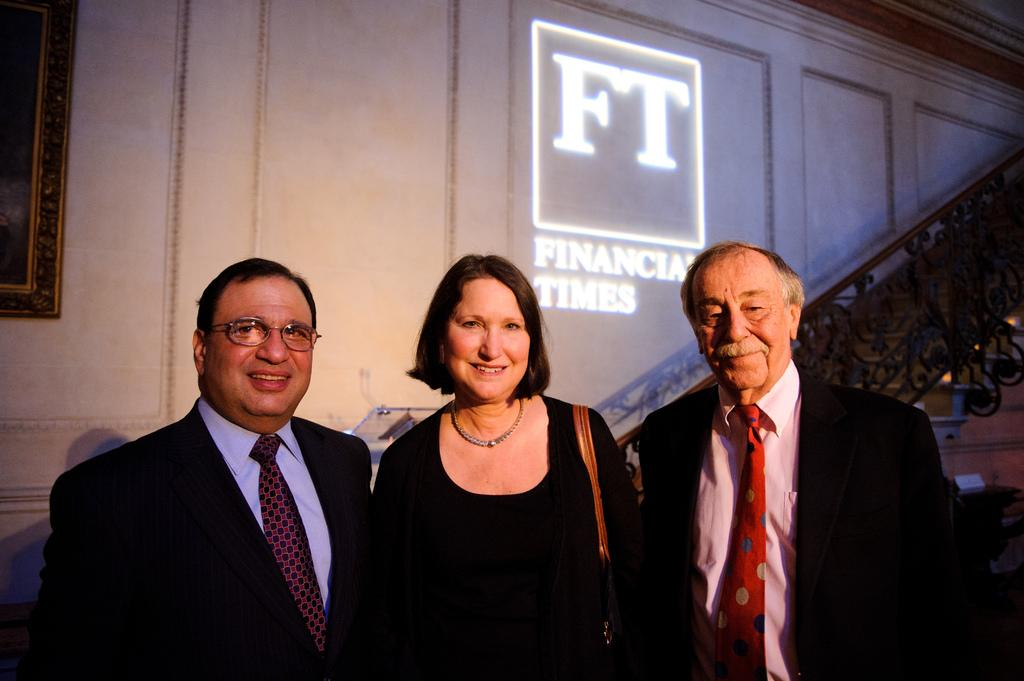How many people are in the image? There are three persons standing in the center of the image. What can be seen in the background of the image? There is a wall and a staircase in the background of the image. What is the staircase railing used for? The staircase railing is used for safety and support while using the staircase. Reasoning: Let's think step by identifying the main subjects and objects in the image based on the provided facts. We then formulate questions that focus on the location and characteristics of these subjects and objects, ensuring that each question can be answered definitively with the information given. We avoid yes/no questions and ensure that the language is simple and clear. Absurd Question/Answer: Can you see the ocean in the background of the image? No, there is no ocean visible in the image. Is there a hole in the floor in the image? No, there is no mention of a hole in the floor in the provided facts. How many geese are depicted on the poster? There are no geese depicted on the poster; it features a picture of a pot. What type of creature is shown interacting with the pot on the poster? There is no creature shown interacting with the pot on the poster; only the pot and letters are present. 